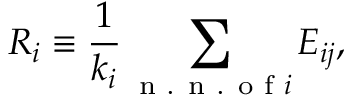<formula> <loc_0><loc_0><loc_500><loc_500>R _ { i } \equiv \frac { 1 } { k _ { i } } \sum _ { { n . n . o f } i } E _ { i j } ,</formula> 